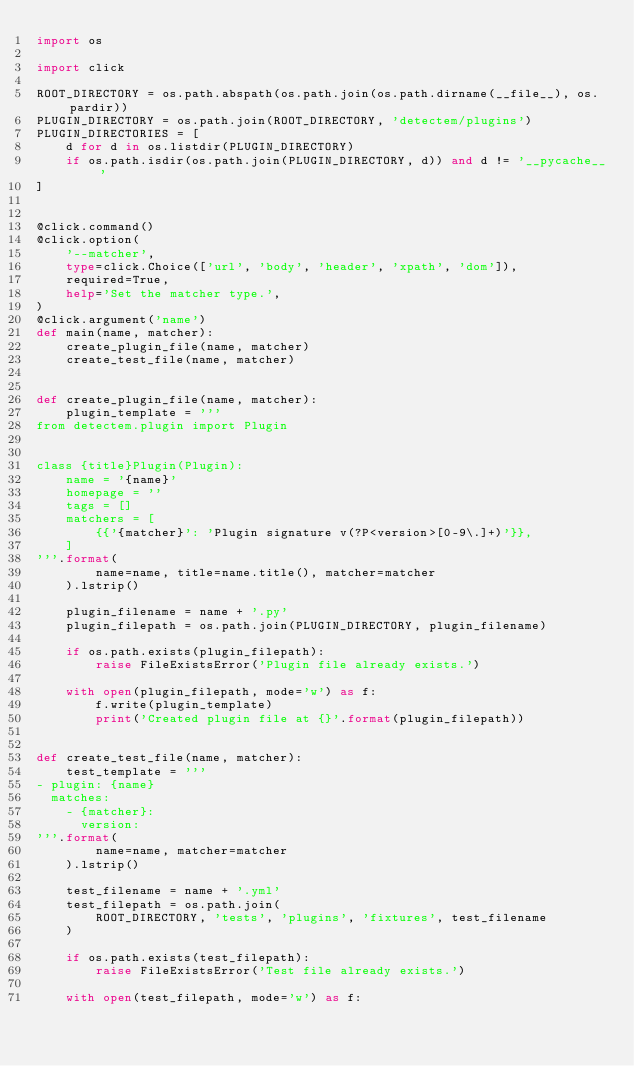<code> <loc_0><loc_0><loc_500><loc_500><_Python_>import os

import click

ROOT_DIRECTORY = os.path.abspath(os.path.join(os.path.dirname(__file__), os.pardir))
PLUGIN_DIRECTORY = os.path.join(ROOT_DIRECTORY, 'detectem/plugins')
PLUGIN_DIRECTORIES = [
    d for d in os.listdir(PLUGIN_DIRECTORY)
    if os.path.isdir(os.path.join(PLUGIN_DIRECTORY, d)) and d != '__pycache__'
]


@click.command()
@click.option(
    '--matcher',
    type=click.Choice(['url', 'body', 'header', 'xpath', 'dom']),
    required=True,
    help='Set the matcher type.',
)
@click.argument('name')
def main(name, matcher):
    create_plugin_file(name, matcher)
    create_test_file(name, matcher)


def create_plugin_file(name, matcher):
    plugin_template = '''
from detectem.plugin import Plugin


class {title}Plugin(Plugin):
    name = '{name}'
    homepage = ''
    tags = []
    matchers = [
        {{'{matcher}': 'Plugin signature v(?P<version>[0-9\.]+)'}},
    ]
'''.format(
        name=name, title=name.title(), matcher=matcher
    ).lstrip()

    plugin_filename = name + '.py'
    plugin_filepath = os.path.join(PLUGIN_DIRECTORY, plugin_filename)

    if os.path.exists(plugin_filepath):
        raise FileExistsError('Plugin file already exists.')

    with open(plugin_filepath, mode='w') as f:
        f.write(plugin_template)
        print('Created plugin file at {}'.format(plugin_filepath))


def create_test_file(name, matcher):
    test_template = '''
- plugin: {name}
  matches:
    - {matcher}:
      version:
'''.format(
        name=name, matcher=matcher
    ).lstrip()

    test_filename = name + '.yml'
    test_filepath = os.path.join(
        ROOT_DIRECTORY, 'tests', 'plugins', 'fixtures', test_filename
    )

    if os.path.exists(test_filepath):
        raise FileExistsError('Test file already exists.')

    with open(test_filepath, mode='w') as f:</code> 